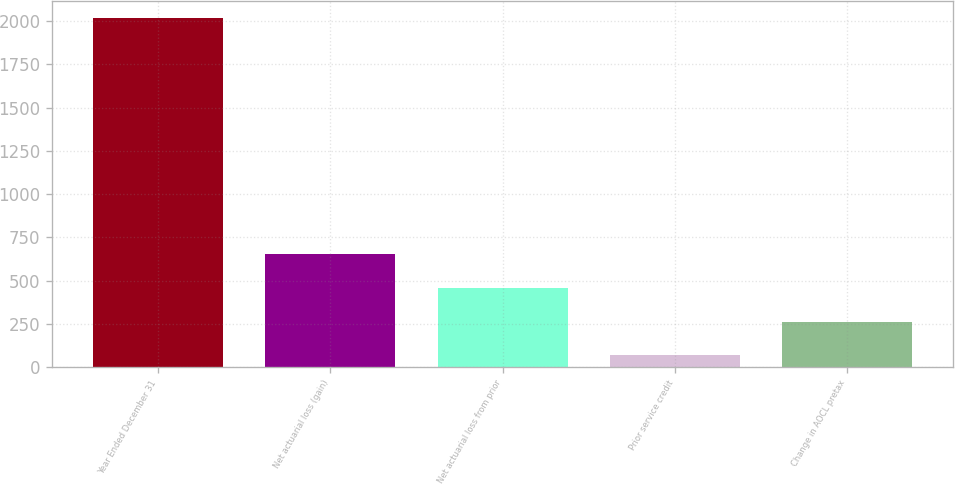Convert chart to OTSL. <chart><loc_0><loc_0><loc_500><loc_500><bar_chart><fcel>Year Ended December 31<fcel>Net actuarial loss (gain)<fcel>Net actuarial loss from prior<fcel>Prior service credit<fcel>Change in AOCL pretax<nl><fcel>2016<fcel>652.4<fcel>457.6<fcel>68<fcel>262.8<nl></chart> 